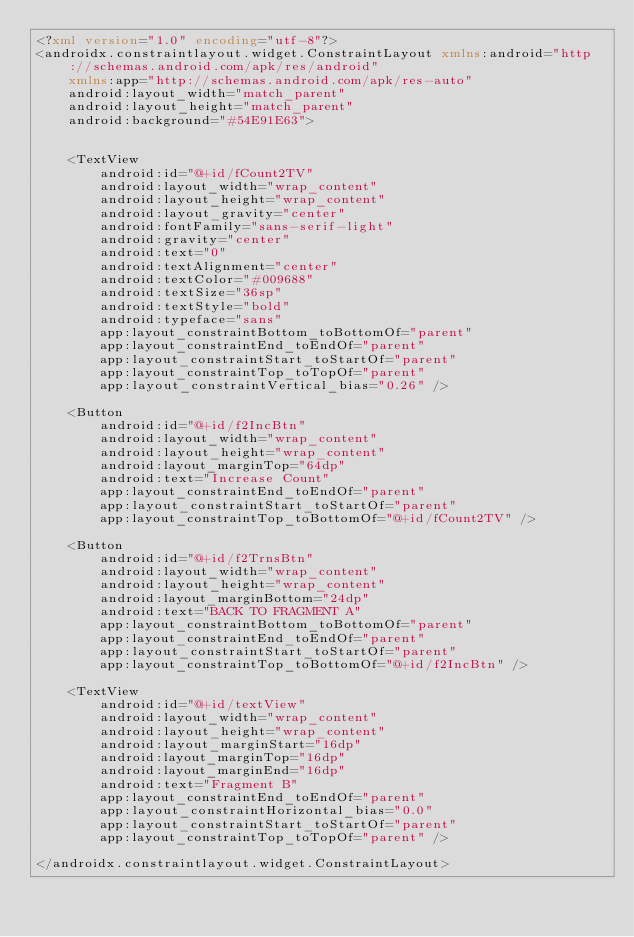Convert code to text. <code><loc_0><loc_0><loc_500><loc_500><_XML_><?xml version="1.0" encoding="utf-8"?>
<androidx.constraintlayout.widget.ConstraintLayout xmlns:android="http://schemas.android.com/apk/res/android"
    xmlns:app="http://schemas.android.com/apk/res-auto"
    android:layout_width="match_parent"
    android:layout_height="match_parent"
    android:background="#54E91E63">


    <TextView
        android:id="@+id/fCount2TV"
        android:layout_width="wrap_content"
        android:layout_height="wrap_content"
        android:layout_gravity="center"
        android:fontFamily="sans-serif-light"
        android:gravity="center"
        android:text="0"
        android:textAlignment="center"
        android:textColor="#009688"
        android:textSize="36sp"
        android:textStyle="bold"
        android:typeface="sans"
        app:layout_constraintBottom_toBottomOf="parent"
        app:layout_constraintEnd_toEndOf="parent"
        app:layout_constraintStart_toStartOf="parent"
        app:layout_constraintTop_toTopOf="parent"
        app:layout_constraintVertical_bias="0.26" />

    <Button
        android:id="@+id/f2IncBtn"
        android:layout_width="wrap_content"
        android:layout_height="wrap_content"
        android:layout_marginTop="64dp"
        android:text="Increase Count"
        app:layout_constraintEnd_toEndOf="parent"
        app:layout_constraintStart_toStartOf="parent"
        app:layout_constraintTop_toBottomOf="@+id/fCount2TV" />

    <Button
        android:id="@+id/f2TrnsBtn"
        android:layout_width="wrap_content"
        android:layout_height="wrap_content"
        android:layout_marginBottom="24dp"
        android:text="BACK TO FRAGMENT A"
        app:layout_constraintBottom_toBottomOf="parent"
        app:layout_constraintEnd_toEndOf="parent"
        app:layout_constraintStart_toStartOf="parent"
        app:layout_constraintTop_toBottomOf="@+id/f2IncBtn" />

    <TextView
        android:id="@+id/textView"
        android:layout_width="wrap_content"
        android:layout_height="wrap_content"
        android:layout_marginStart="16dp"
        android:layout_marginTop="16dp"
        android:layout_marginEnd="16dp"
        android:text="Fragment B"
        app:layout_constraintEnd_toEndOf="parent"
        app:layout_constraintHorizontal_bias="0.0"
        app:layout_constraintStart_toStartOf="parent"
        app:layout_constraintTop_toTopOf="parent" />

</androidx.constraintlayout.widget.ConstraintLayout></code> 